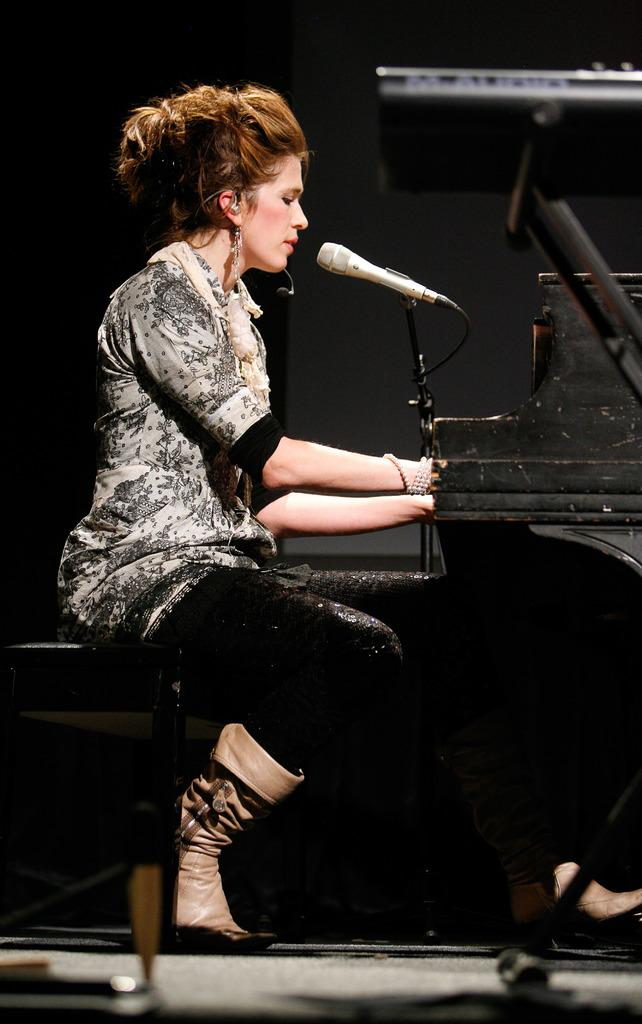Who is the main subject in the picture? There is a lady in the picture. What is the lady doing in the image? The lady is sitting on a chair and appears to be singing into a microphone. What object is in front of the lady? There is a piano in front of the lady. Where is the boy with the kitten playing in the image? There is no boy or kitten present in the image; it only features a lady sitting on a chair and singing into a microphone. How many sheep can be seen grazing in the background of the image? There are no sheep visible in the image. 